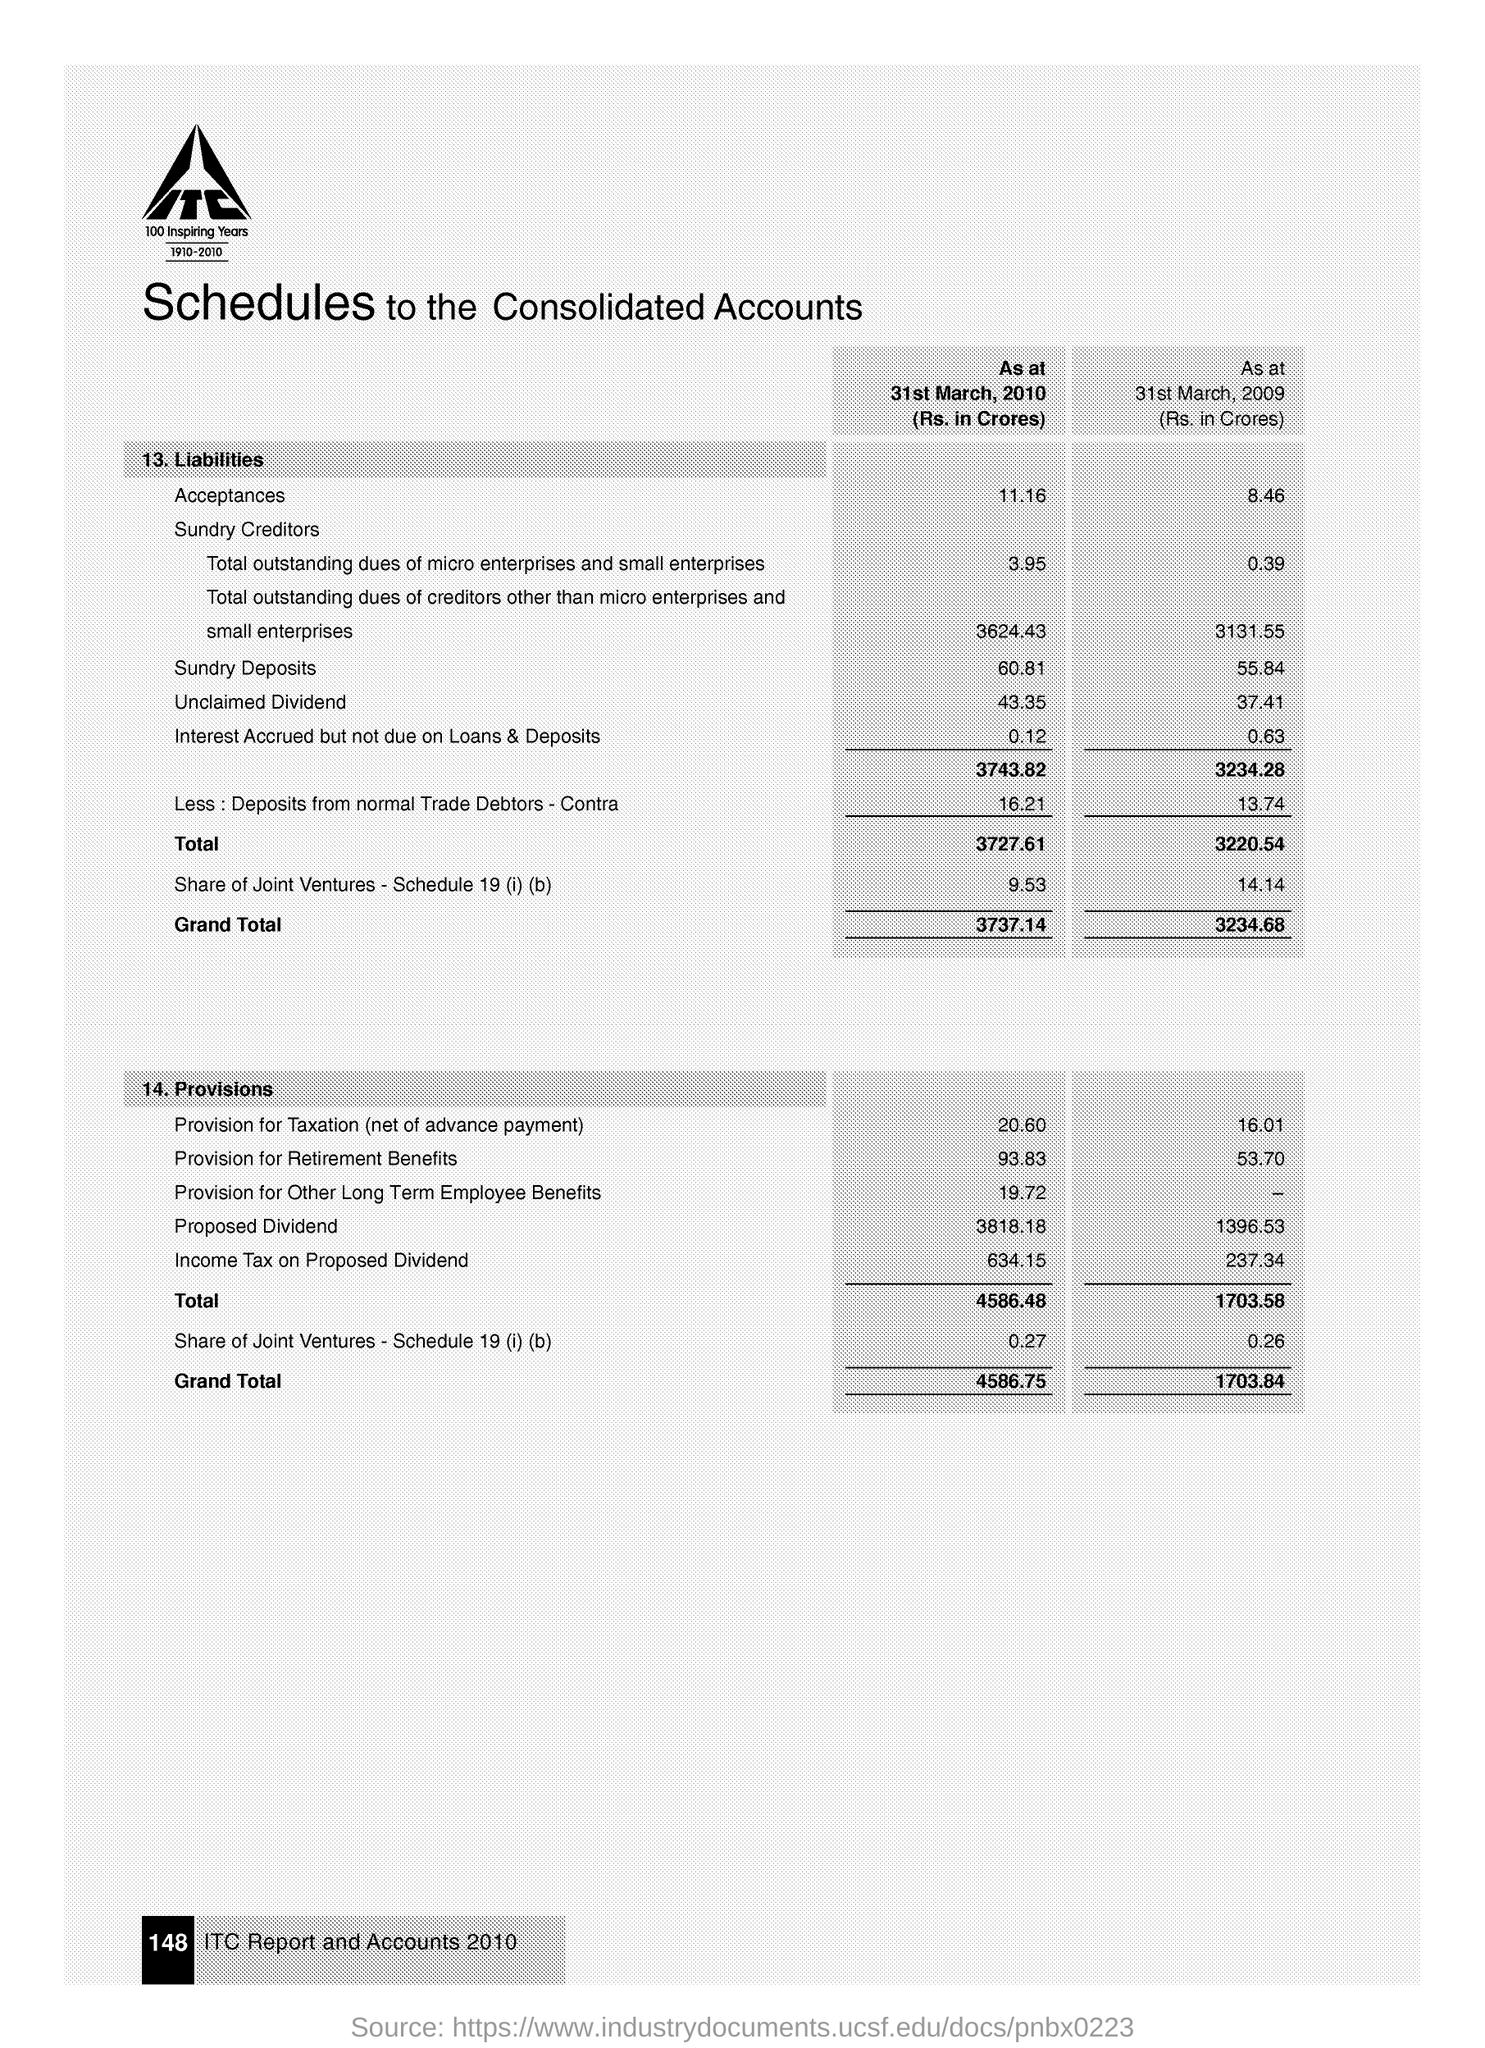Specify some key components in this picture. The grand total of liabilities as of March 31, 2009 was 3,234.68. The total of provisions as of March 31, 2010, was 4586.48. As of March 31, 2009, the sundry deposits were 55.84. On March 31, 2010, the acceptance of liabilities was 11.16. 